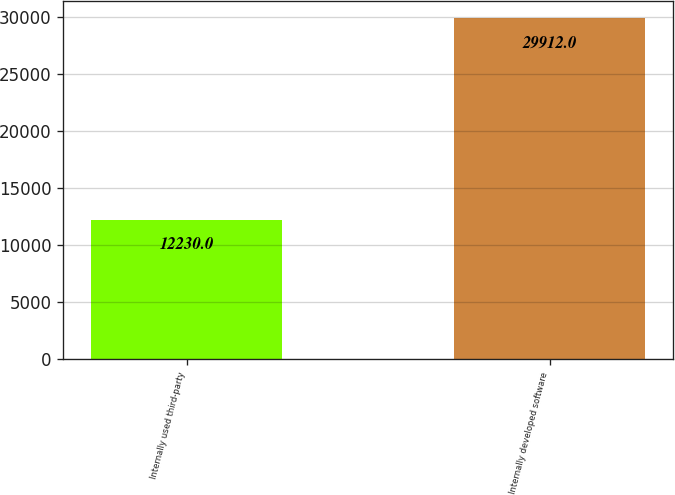Convert chart. <chart><loc_0><loc_0><loc_500><loc_500><bar_chart><fcel>Internally used third-party<fcel>Internally developed software<nl><fcel>12230<fcel>29912<nl></chart> 